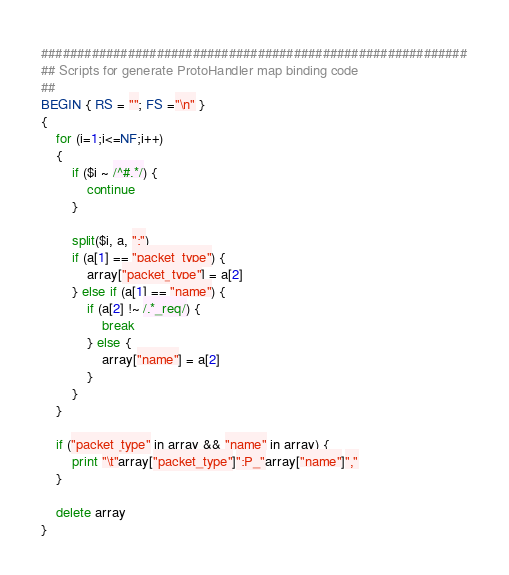Convert code to text. <code><loc_0><loc_0><loc_500><loc_500><_Awk_>###########################################################
## Scripts for generate ProtoHandler map binding code
##
BEGIN { RS = ""; FS ="\n" }
{
	for (i=1;i<=NF;i++)
	{
		if ($i ~ /^#.*/) {
			continue
		}

		split($i, a, ":")
		if (a[1] == "packet_type") {
			array["packet_type"] = a[2]
		} else if (a[1] == "name") {
			if (a[2] !~ /.*_req/) {
				break
			} else {
				array["name"] = a[2]
			}
		}
	}

	if ("packet_type" in array && "name" in array) {
		print "\t"array["packet_type"]":P_"array["name"]","
	}

	delete array
}
</code> 